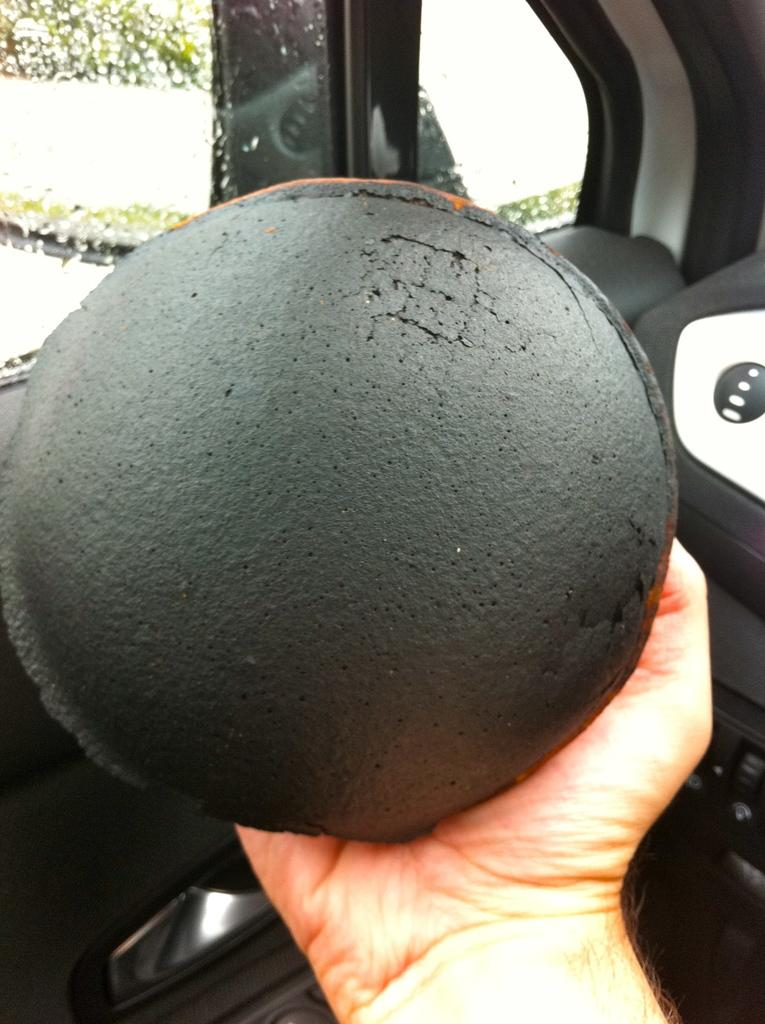What is the main subject in the foreground of the image? There is a person in the foreground of the image. What is the person holding in their hand? The person is holding a ball in their hand. What object can be seen in the image besides the person and the ball? There is a glass in the image. What can be seen through the glass in the background? Trees are visible through the glass in the background. How many cows are visible through the glass in the image? There are no cows visible through the glass in the image; only trees can be seen. What type of wrench is being used by the person in the image? There is no wrench present in the image; the person is holding a ball. 